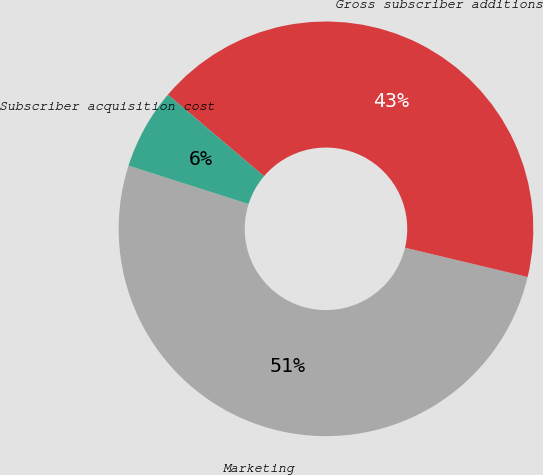<chart> <loc_0><loc_0><loc_500><loc_500><pie_chart><fcel>Marketing<fcel>Gross subscriber additions<fcel>Subscriber acquisition cost<nl><fcel>51.2%<fcel>42.53%<fcel>6.27%<nl></chart> 